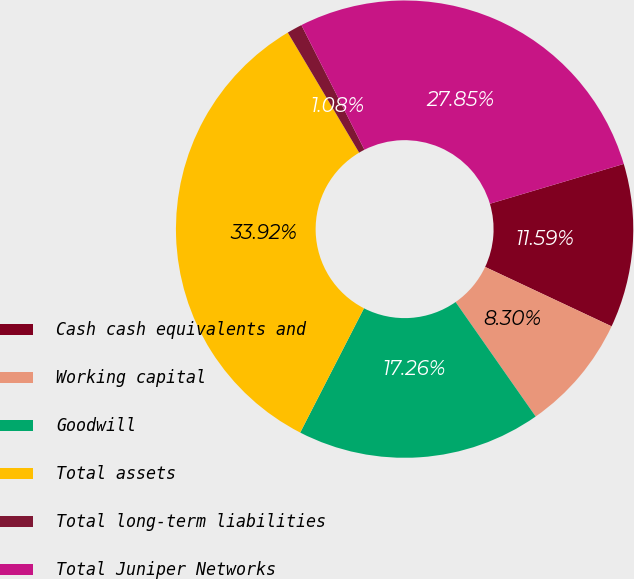Convert chart to OTSL. <chart><loc_0><loc_0><loc_500><loc_500><pie_chart><fcel>Cash cash equivalents and<fcel>Working capital<fcel>Goodwill<fcel>Total assets<fcel>Total long-term liabilities<fcel>Total Juniper Networks<nl><fcel>11.59%<fcel>8.3%<fcel>17.26%<fcel>33.92%<fcel>1.08%<fcel>27.85%<nl></chart> 